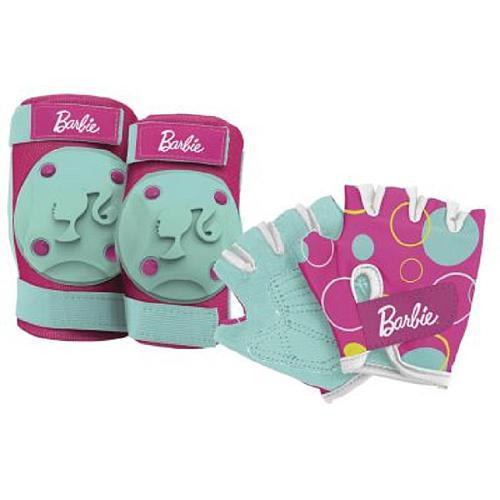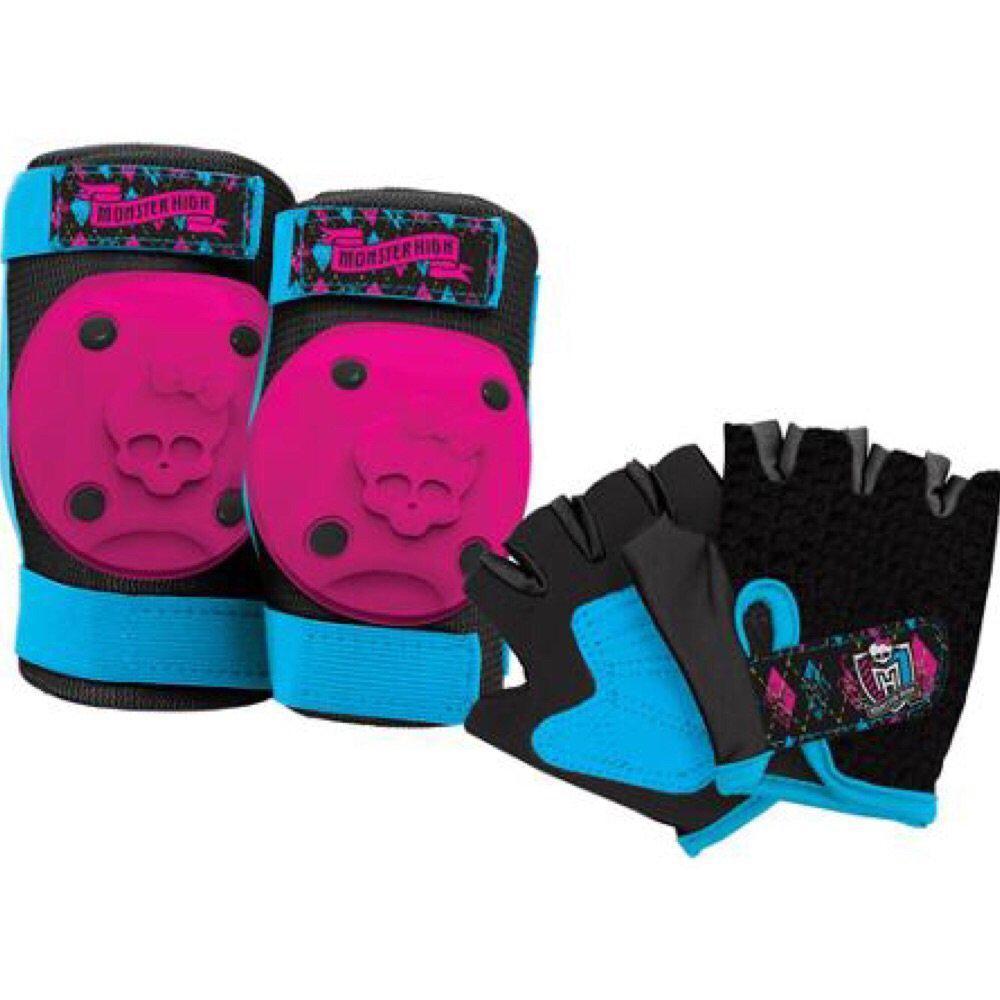The first image is the image on the left, the second image is the image on the right. For the images shown, is this caption "One image contains exactly two roller skates and two pads." true? Answer yes or no. No. The first image is the image on the left, the second image is the image on the right. Assess this claim about the two images: "All images have both knee pads and gloves.". Correct or not? Answer yes or no. Yes. 